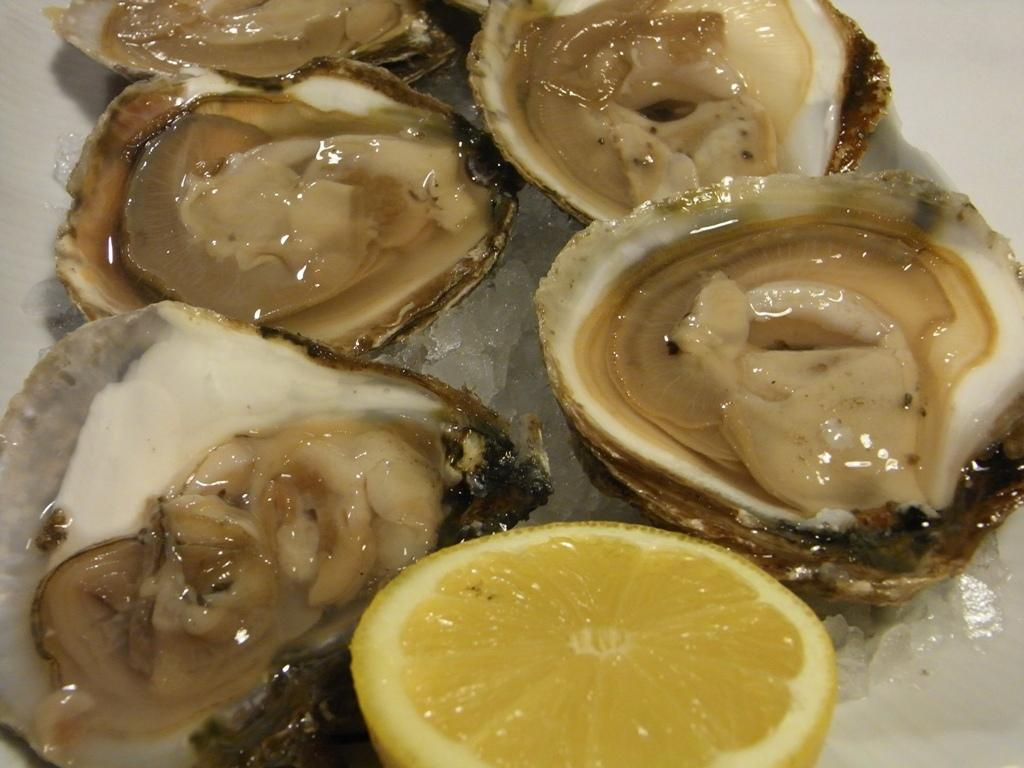What types of food items can be seen in the image? There are food items in the image, but the specific types are not mentioned. Can you identify any specific fruit among the food items? Yes, a lemon is present among the food items. What type of frog can be seen interacting with the lemon in the image? There is no frog present in the image, and therefore no such interaction can be observed. What type of society is depicted in the image? The image does not depict any society; it only shows food items and a lemon. 